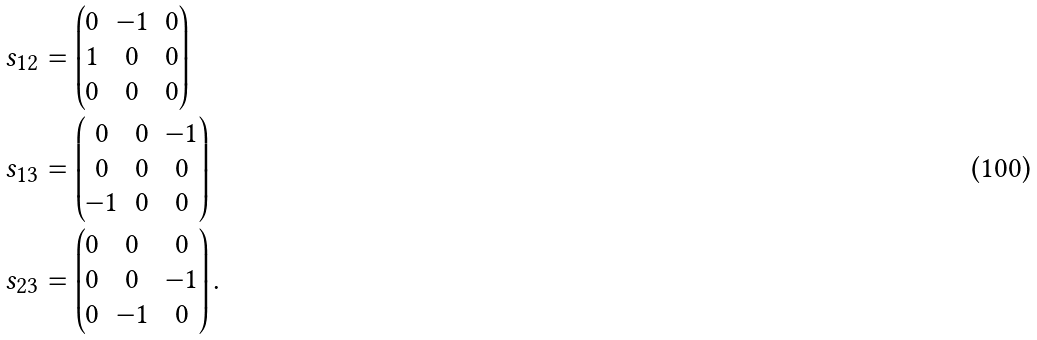<formula> <loc_0><loc_0><loc_500><loc_500>s _ { 1 2 } & = \begin{pmatrix} 0 & - 1 & 0 \\ 1 & 0 & 0 \\ 0 & 0 & 0 \end{pmatrix} \\ s _ { 1 3 } & = \begin{pmatrix} 0 & 0 & - 1 \\ 0 & 0 & 0 \\ - 1 & 0 & 0 \end{pmatrix} \\ s _ { 2 3 } & = \begin{pmatrix} 0 & 0 & 0 \\ 0 & 0 & - 1 \\ 0 & - 1 & 0 \end{pmatrix} .</formula> 